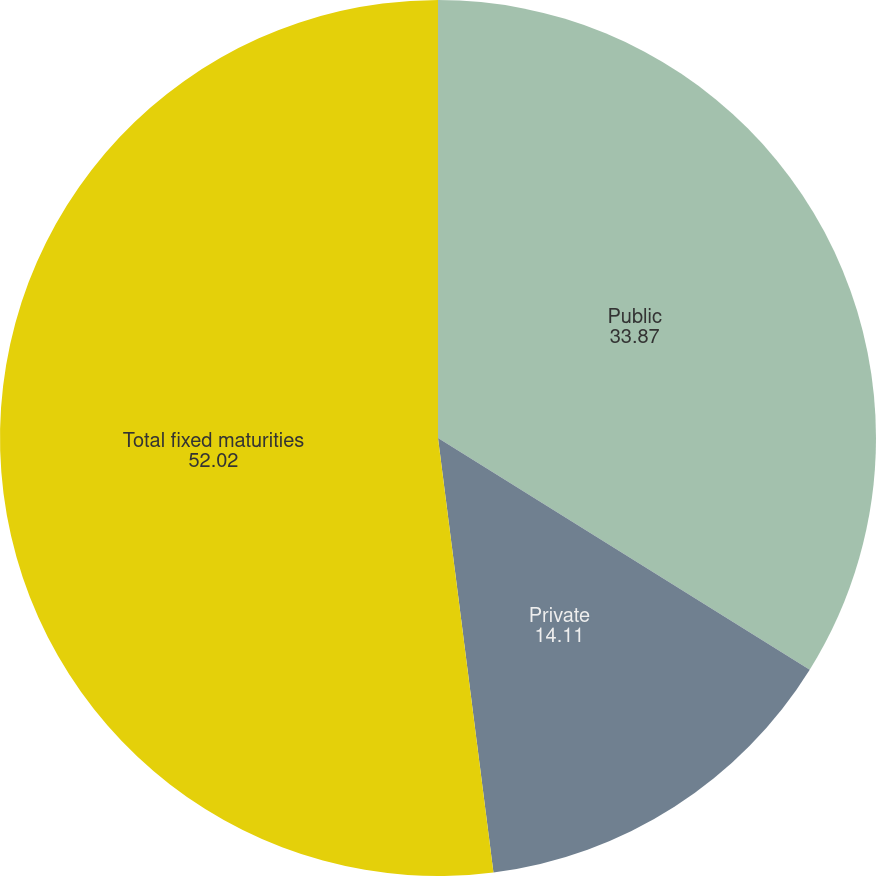Convert chart. <chart><loc_0><loc_0><loc_500><loc_500><pie_chart><fcel>Public<fcel>Private<fcel>Total fixed maturities<nl><fcel>33.87%<fcel>14.11%<fcel>52.02%<nl></chart> 